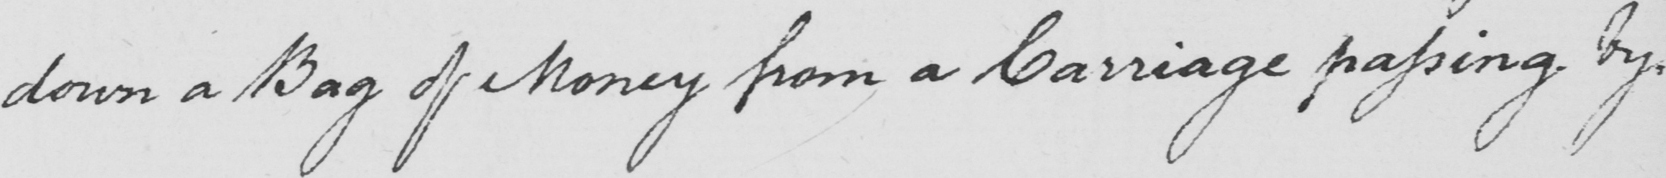What text is written in this handwritten line? down a Bag of Money from a Carriage passing by . 